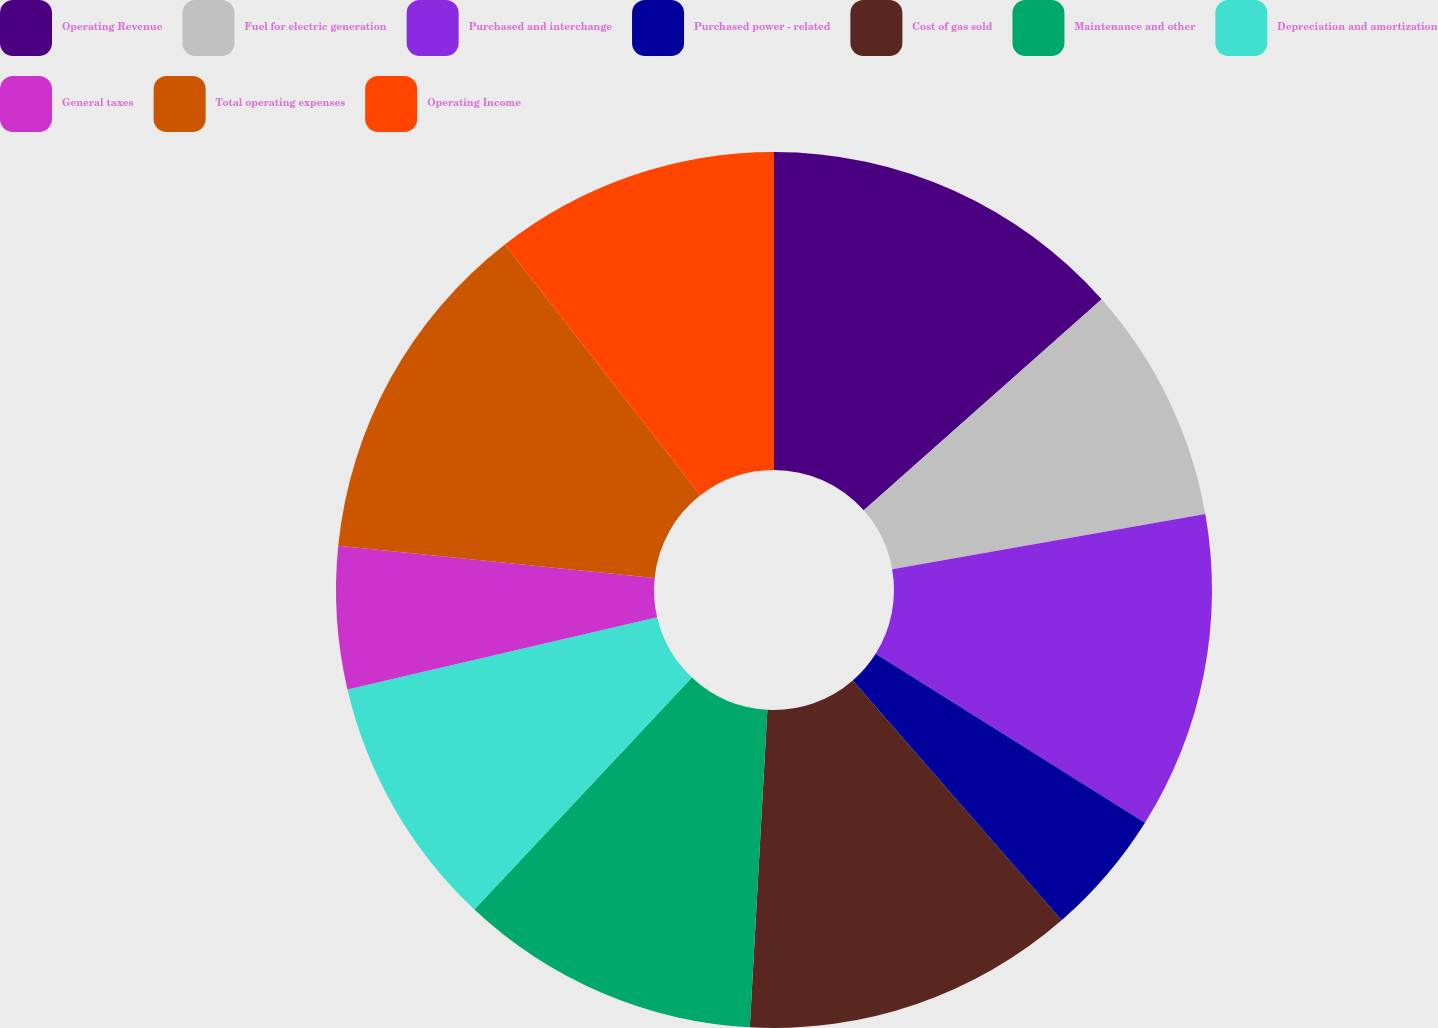Convert chart. <chart><loc_0><loc_0><loc_500><loc_500><pie_chart><fcel>Operating Revenue<fcel>Fuel for electric generation<fcel>Purchased and interchange<fcel>Purchased power - related<fcel>Cost of gas sold<fcel>Maintenance and other<fcel>Depreciation and amortization<fcel>General taxes<fcel>Total operating expenses<fcel>Operating Income<nl><fcel>13.45%<fcel>8.77%<fcel>11.7%<fcel>4.68%<fcel>12.28%<fcel>11.11%<fcel>9.36%<fcel>5.26%<fcel>12.86%<fcel>10.53%<nl></chart> 